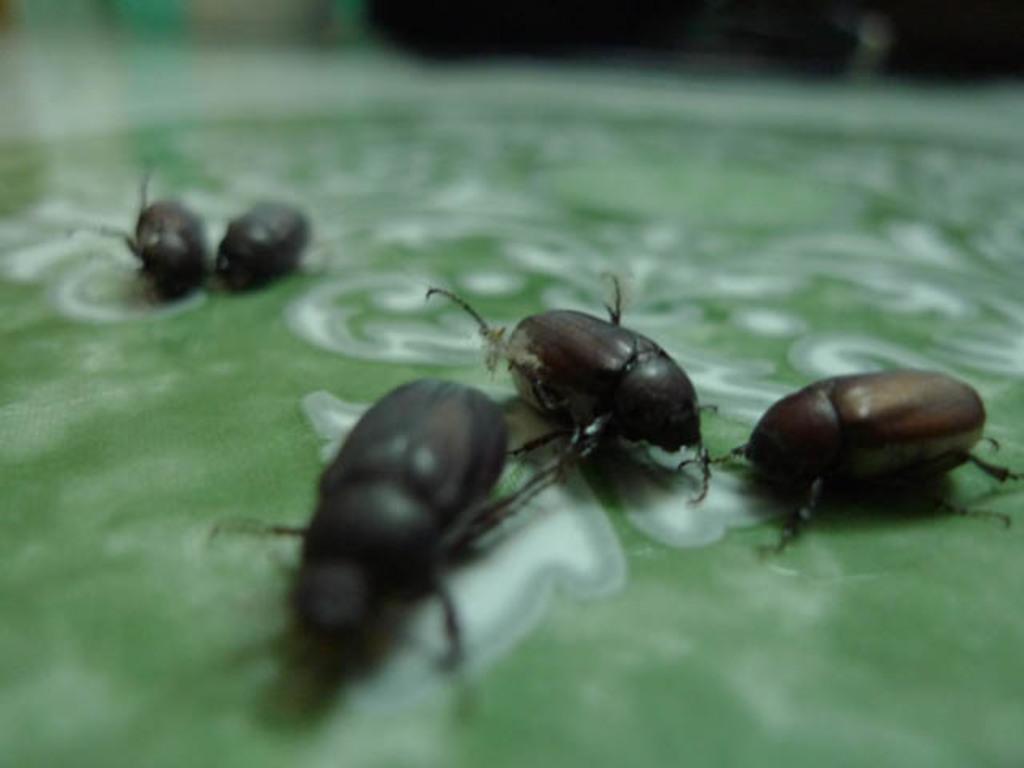How would you summarize this image in a sentence or two? In the picture there is a leaf, on the leaf there are bugs present. 